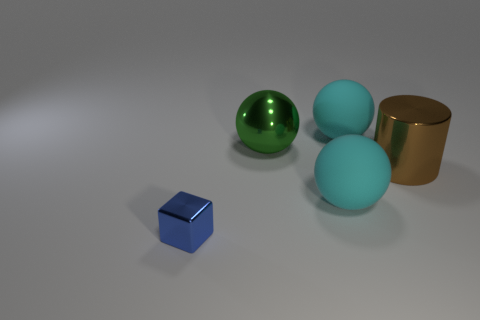Subtract all big cyan rubber balls. How many balls are left? 1 Add 3 yellow objects. How many objects exist? 8 Subtract all cyan spheres. How many spheres are left? 1 Subtract 2 spheres. How many spheres are left? 1 Subtract all blue blocks. How many green spheres are left? 1 Add 5 metallic cubes. How many metallic cubes are left? 6 Add 4 cyan spheres. How many cyan spheres exist? 6 Subtract 0 blue cylinders. How many objects are left? 5 Subtract all spheres. How many objects are left? 2 Subtract all blue balls. Subtract all brown cylinders. How many balls are left? 3 